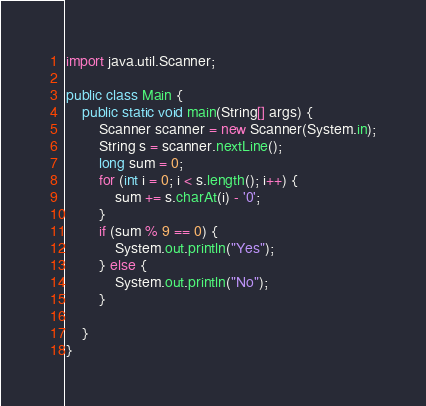<code> <loc_0><loc_0><loc_500><loc_500><_Java_>import java.util.Scanner;

public class Main {
    public static void main(String[] args) {
        Scanner scanner = new Scanner(System.in);
        String s = scanner.nextLine();
        long sum = 0;
        for (int i = 0; i < s.length(); i++) {
            sum += s.charAt(i) - '0';
        }
        if (sum % 9 == 0) {
            System.out.println("Yes");
        } else {
            System.out.println("No");
        }

    }
}</code> 